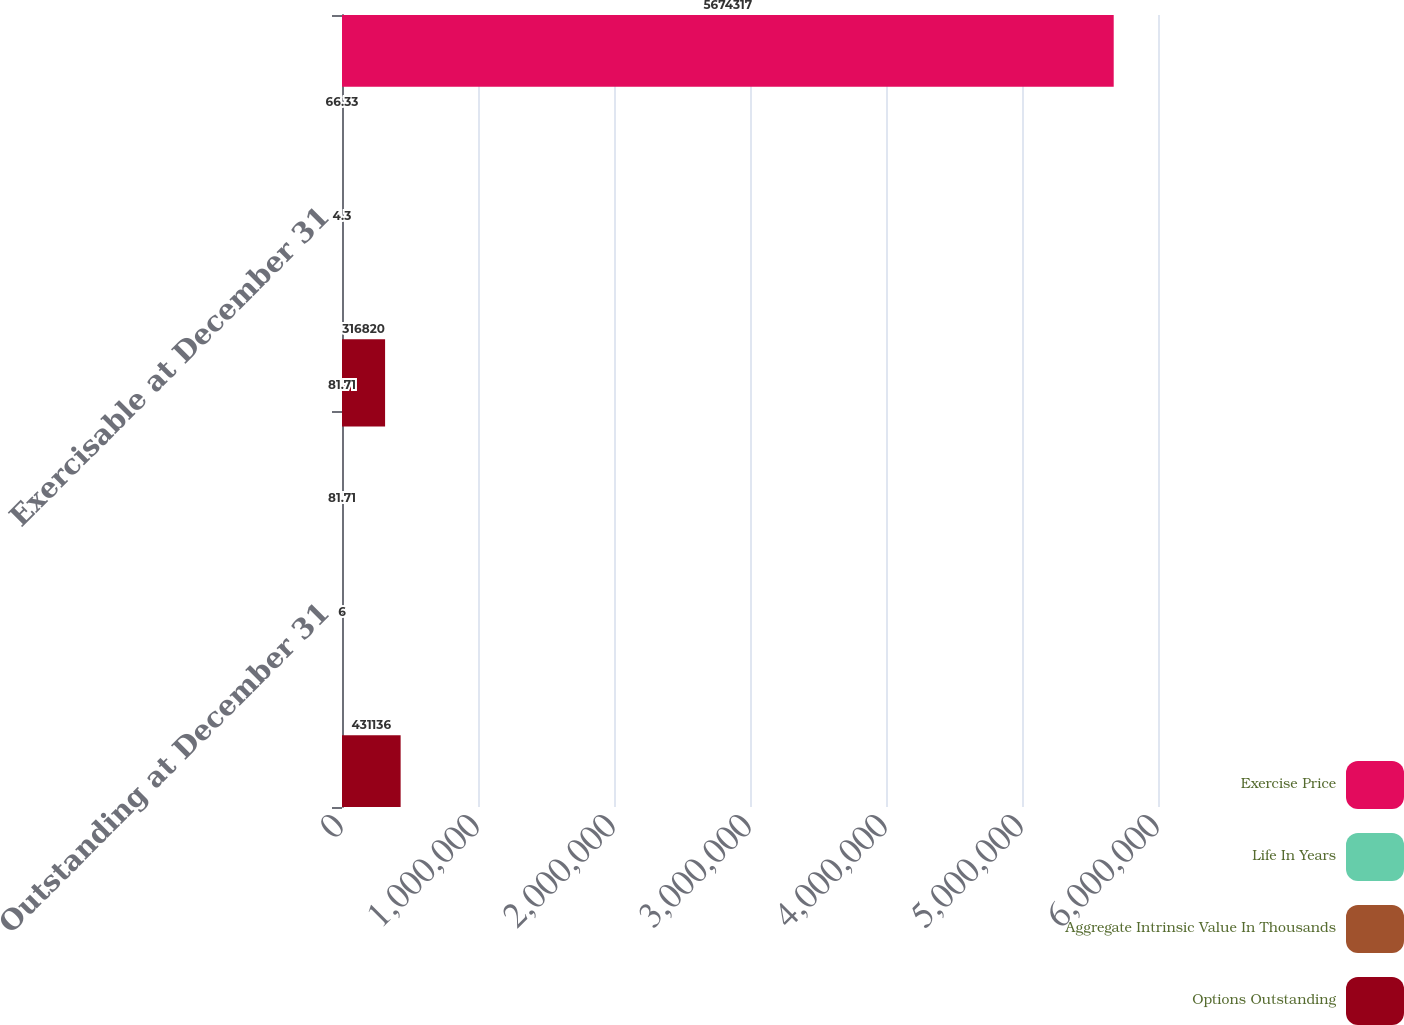<chart> <loc_0><loc_0><loc_500><loc_500><stacked_bar_chart><ecel><fcel>Outstanding at December 31<fcel>Exercisable at December 31<nl><fcel>Exercise Price<fcel>81.71<fcel>5.67432e+06<nl><fcel>Life In Years<fcel>81.71<fcel>66.33<nl><fcel>Aggregate Intrinsic Value In Thousands<fcel>6<fcel>4.3<nl><fcel>Options Outstanding<fcel>431136<fcel>316820<nl></chart> 